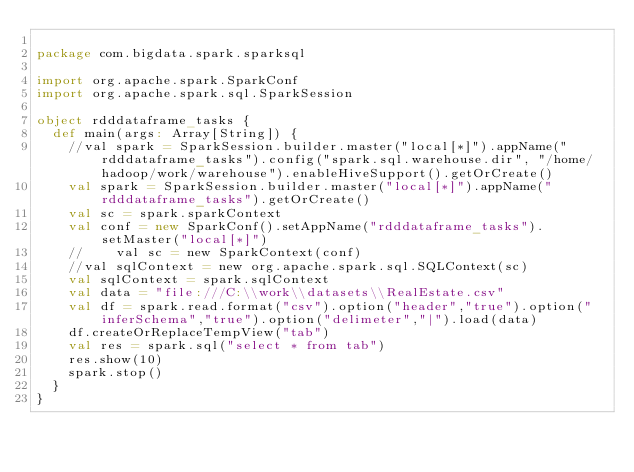Convert code to text. <code><loc_0><loc_0><loc_500><loc_500><_Scala_>
package com.bigdata.spark.sparksql

import org.apache.spark.SparkConf
import org.apache.spark.sql.SparkSession

object rdddataframe_tasks {
  def main(args: Array[String]) {
    //val spark = SparkSession.builder.master("local[*]").appName("rdddataframe_tasks").config("spark.sql.warehouse.dir", "/home/hadoop/work/warehouse").enableHiveSupport().getOrCreate()
    val spark = SparkSession.builder.master("local[*]").appName("rdddataframe_tasks").getOrCreate()
    val sc = spark.sparkContext
    val conf = new SparkConf().setAppName("rdddataframe_tasks").setMaster("local[*]")
    //    val sc = new SparkContext(conf)
    //val sqlContext = new org.apache.spark.sql.SQLContext(sc)
    val sqlContext = spark.sqlContext
    val data = "file:///C:\\work\\datasets\\RealEstate.csv"
    val df = spark.read.format("csv").option("header","true").option("inferSchema","true").option("delimeter","|").load(data)
    df.createOrReplaceTempView("tab")
    val res = spark.sql("select * from tab")
    res.show(10)
    spark.stop()
  }
}

</code> 